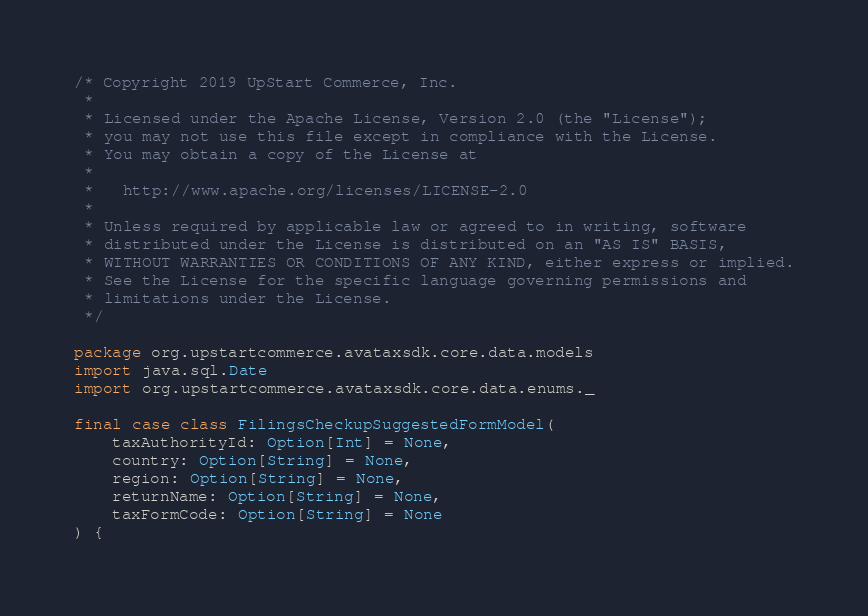<code> <loc_0><loc_0><loc_500><loc_500><_Scala_>/* Copyright 2019 UpStart Commerce, Inc.
 *
 * Licensed under the Apache License, Version 2.0 (the "License");
 * you may not use this file except in compliance with the License.
 * You may obtain a copy of the License at
 *
 *   http://www.apache.org/licenses/LICENSE-2.0
 *
 * Unless required by applicable law or agreed to in writing, software
 * distributed under the License is distributed on an "AS IS" BASIS,
 * WITHOUT WARRANTIES OR CONDITIONS OF ANY KIND, either express or implied.
 * See the License for the specific language governing permissions and
 * limitations under the License.
 */

package org.upstartcommerce.avataxsdk.core.data.models
import java.sql.Date
import org.upstartcommerce.avataxsdk.core.data.enums._

final case class FilingsCheckupSuggestedFormModel(
    taxAuthorityId: Option[Int] = None,
    country: Option[String] = None,
    region: Option[String] = None,
    returnName: Option[String] = None,
    taxFormCode: Option[String] = None
) {
</code> 